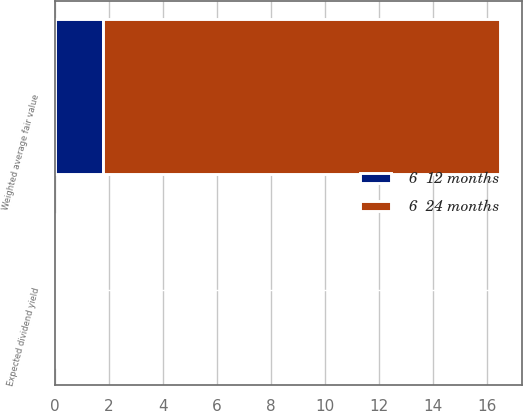Convert chart. <chart><loc_0><loc_0><loc_500><loc_500><stacked_bar_chart><ecel><fcel>Expected dividend yield<fcel>Weighted average fair value<nl><fcel>6  24 months<fcel>0<fcel>14.66<nl><fcel>6  12 months<fcel>0<fcel>1.81<nl></chart> 